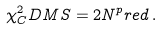Convert formula to latex. <formula><loc_0><loc_0><loc_500><loc_500>\chi ^ { 2 } _ { C } D M S = 2 N ^ { p } r e d \, .</formula> 